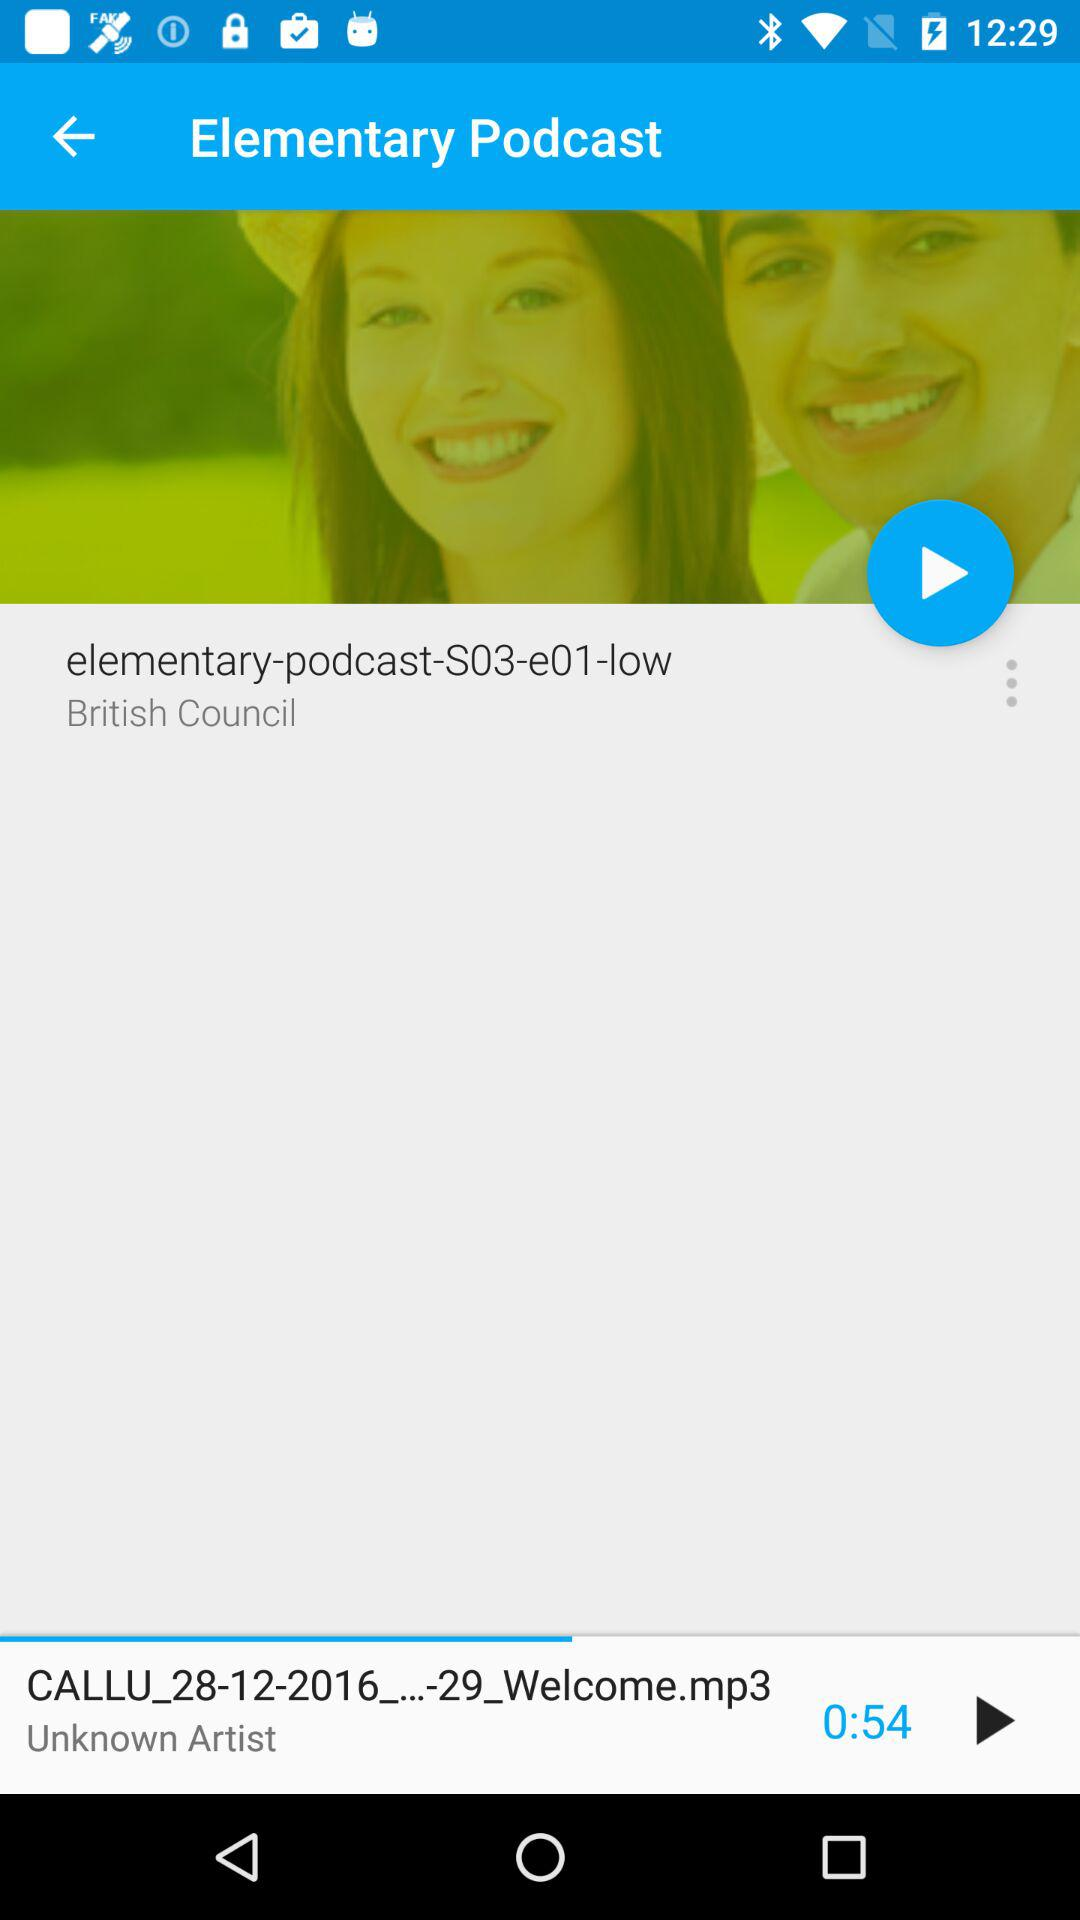Which clip was last played? The last played clip was "CALLU_28-12-2016_...-29_Welcome.mp3". 